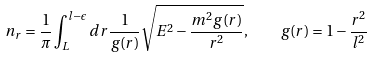<formula> <loc_0><loc_0><loc_500><loc_500>n _ { r } = \frac { 1 } { \pi } \int _ { L } ^ { l - \epsilon } d r \frac { 1 } { g ( r ) } \sqrt { { E ^ { 2 } - \frac { m ^ { 2 } g ( r ) } { r ^ { 2 } } } } , \quad g ( r ) = 1 - \frac { r ^ { 2 } } { l ^ { 2 } }</formula> 